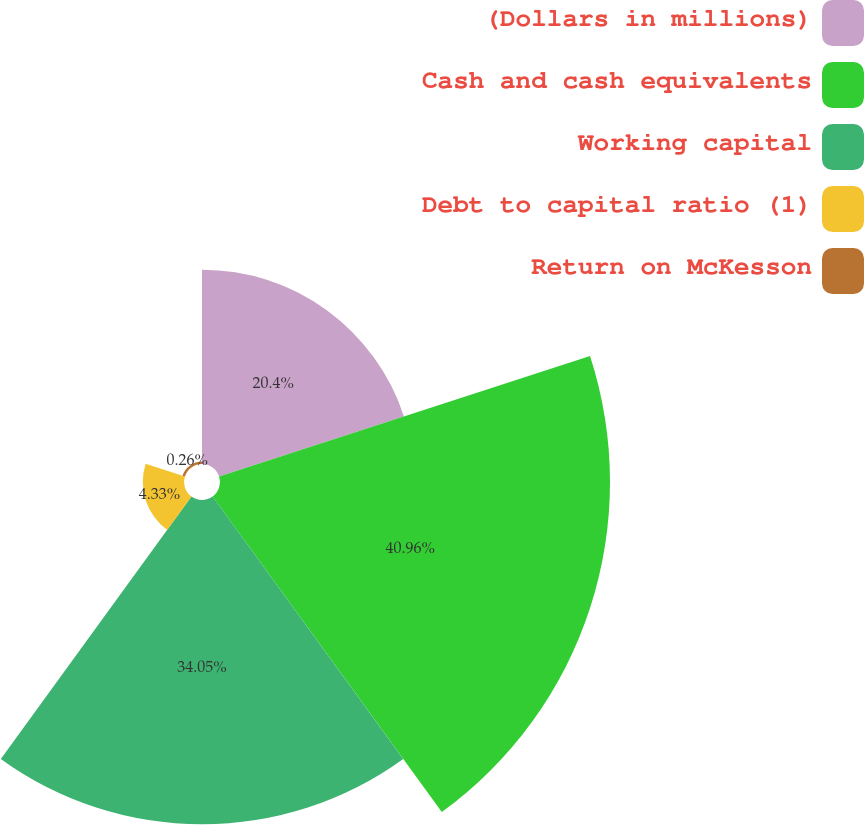<chart> <loc_0><loc_0><loc_500><loc_500><pie_chart><fcel>(Dollars in millions)<fcel>Cash and cash equivalents<fcel>Working capital<fcel>Debt to capital ratio (1)<fcel>Return on McKesson<nl><fcel>20.4%<fcel>40.95%<fcel>34.05%<fcel>4.33%<fcel>0.26%<nl></chart> 